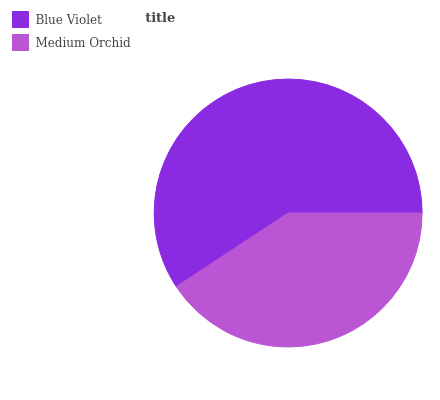Is Medium Orchid the minimum?
Answer yes or no. Yes. Is Blue Violet the maximum?
Answer yes or no. Yes. Is Medium Orchid the maximum?
Answer yes or no. No. Is Blue Violet greater than Medium Orchid?
Answer yes or no. Yes. Is Medium Orchid less than Blue Violet?
Answer yes or no. Yes. Is Medium Orchid greater than Blue Violet?
Answer yes or no. No. Is Blue Violet less than Medium Orchid?
Answer yes or no. No. Is Blue Violet the high median?
Answer yes or no. Yes. Is Medium Orchid the low median?
Answer yes or no. Yes. Is Medium Orchid the high median?
Answer yes or no. No. Is Blue Violet the low median?
Answer yes or no. No. 